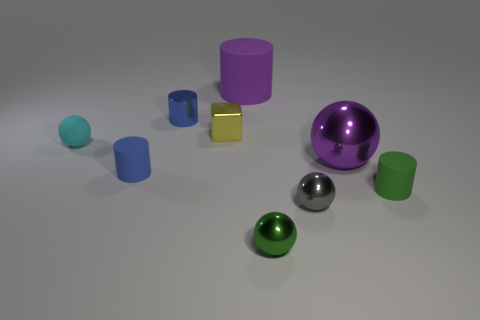There is a tiny rubber thing that is the same color as the metal cylinder; what shape is it?
Offer a very short reply. Cylinder. What is the shape of the tiny green thing that is made of the same material as the large cylinder?
Make the answer very short. Cylinder. Do the blue metallic object and the green metal thing have the same shape?
Make the answer very short. No. The big matte thing is what color?
Your answer should be compact. Purple. What number of objects are either tiny gray metallic spheres or metal things?
Provide a short and direct response. 5. Is there any other thing that is the same material as the cyan ball?
Provide a short and direct response. Yes. Are there fewer gray balls that are behind the big purple sphere than green rubber things?
Your answer should be compact. Yes. Are there more small cylinders in front of the small green matte thing than balls left of the rubber sphere?
Provide a succinct answer. No. Is there any other thing that has the same color as the cube?
Offer a terse response. No. What material is the big purple thing that is in front of the small cyan sphere?
Make the answer very short. Metal. 